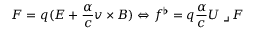Convert formula to latex. <formula><loc_0><loc_0><loc_500><loc_500>F = q ( E + \frac { \alpha } { c } v \times B ) \Leftrightarrow f ^ { \flat } = q \frac { \alpha } { c } U \lrcorner F</formula> 